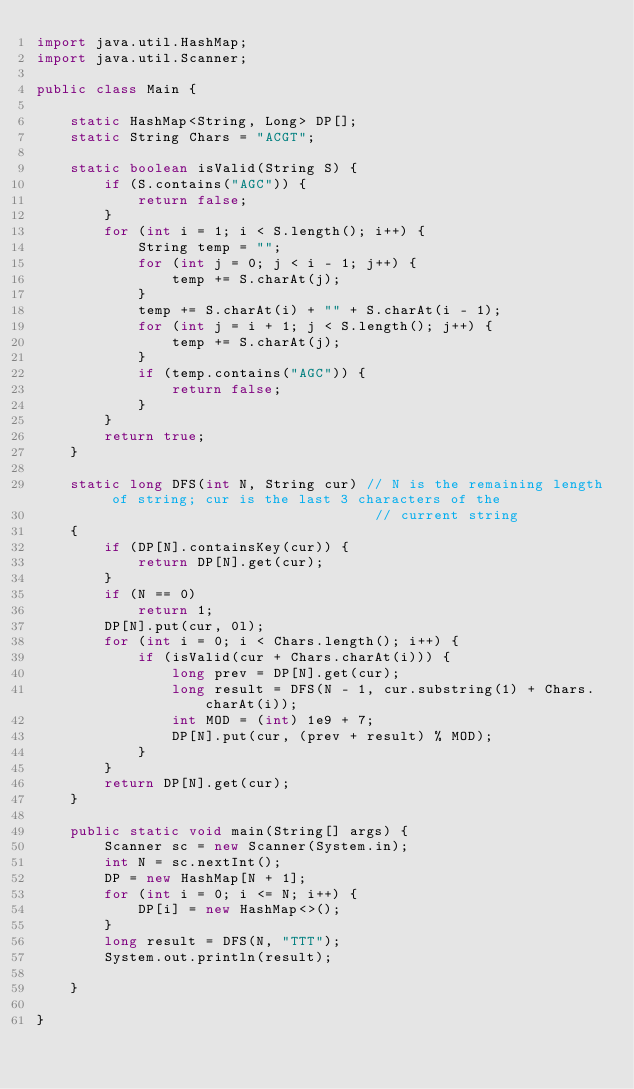Convert code to text. <code><loc_0><loc_0><loc_500><loc_500><_Java_>import java.util.HashMap;
import java.util.Scanner;

public class Main {

	static HashMap<String, Long> DP[];
	static String Chars = "ACGT";

	static boolean isValid(String S) {
		if (S.contains("AGC")) {
			return false;
		}
		for (int i = 1; i < S.length(); i++) {
			String temp = "";
			for (int j = 0; j < i - 1; j++) {
				temp += S.charAt(j);
			}
			temp += S.charAt(i) + "" + S.charAt(i - 1);
			for (int j = i + 1; j < S.length(); j++) {
				temp += S.charAt(j);
			}
			if (temp.contains("AGC")) {
				return false;
			}
		}
		return true;
	}

	static long DFS(int N, String cur) // N is the remaining length of string; cur is the last 3 characters of the
										// current string
	{
		if (DP[N].containsKey(cur)) {
			return DP[N].get(cur);
		}
		if (N == 0)
			return 1;
		DP[N].put(cur, 0l);
		for (int i = 0; i < Chars.length(); i++) {
			if (isValid(cur + Chars.charAt(i))) {
				long prev = DP[N].get(cur);
				long result = DFS(N - 1, cur.substring(1) + Chars.charAt(i));
				int MOD = (int) 1e9 + 7;
				DP[N].put(cur, (prev + result) % MOD);
			}
		}
		return DP[N].get(cur);
	}

	public static void main(String[] args) {
		Scanner sc = new Scanner(System.in);
		int N = sc.nextInt();
		DP = new HashMap[N + 1];
		for (int i = 0; i <= N; i++) {
			DP[i] = new HashMap<>();
		}
		long result = DFS(N, "TTT");
		System.out.println(result);

	}

}
</code> 